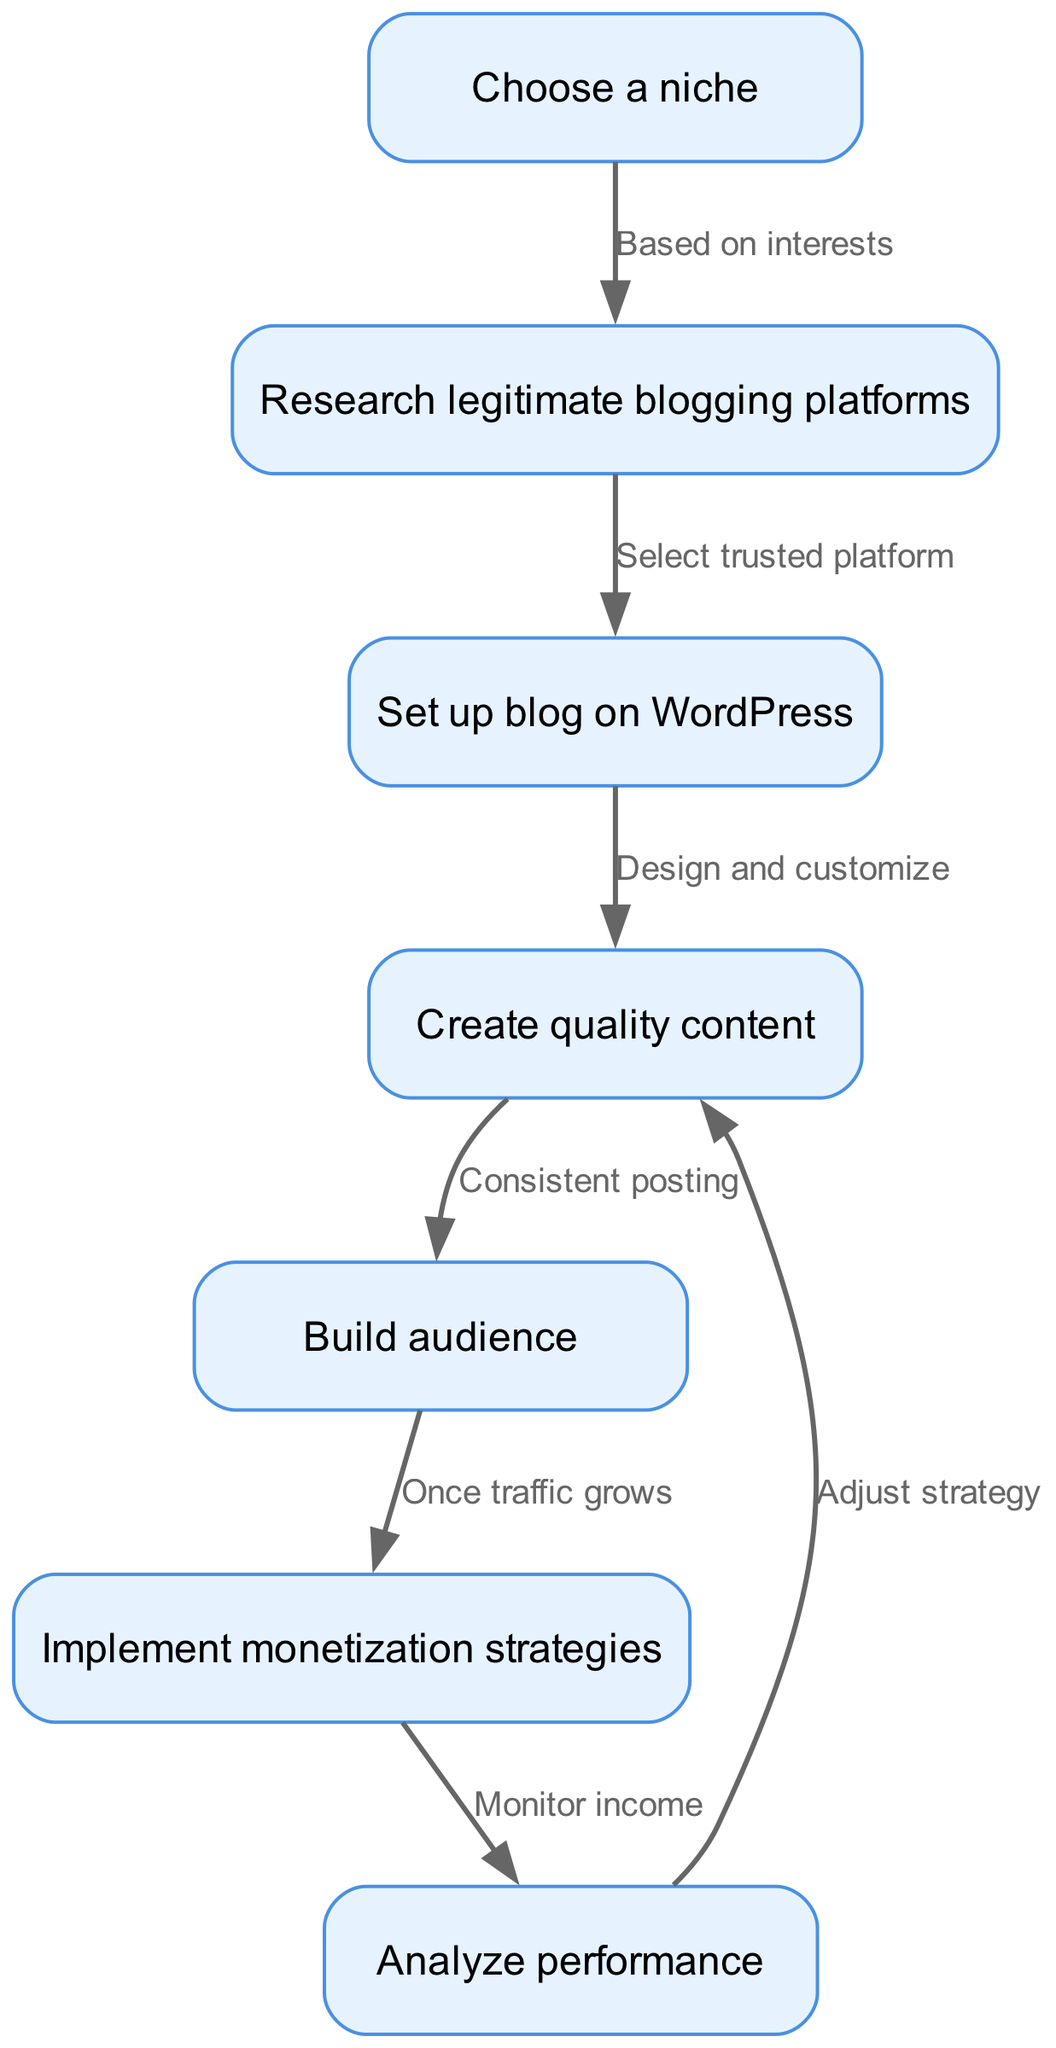What is the first step in creating a blog? The diagram shows the first node as "Choose a niche," indicating that identifying a specific area of interest is the initial step.
Answer: Choose a niche How many nodes are present in the flow chart? The diagram consists of seven nodes, each representing a distinct step in the blogging process.
Answer: 7 What relationship exists between "Build audience" and "Implement monetization strategies"? The flow chart indicates that "Implement monetization strategies" follows from "Build audience" and specifies that it occurs "once traffic grows," highlighting the conditional relationship based on audience growth.
Answer: Once traffic grows What is the last step in the blogging process? According to the flow chart, the final node is "Analyze performance," showing that performance evaluation is the conclusive step after monetization strategies are implemented.
Answer: Analyze performance What does "Create quality content" lead to? The flow chart indicates that "Create quality content" leads to "Build audience," meaning that producing high-quality content is essential for attracting readers.
Answer: Build audience Which node is directly connected to "Set up blog on WordPress"? The diagram shows that "Set up blog on WordPress" is directly followed by "Create quality content," illustrating that once the blog is set up, the next step is to focus on content creation.
Answer: Create quality content What is required to progress from "Choose a niche" to "Research legitimate blogging platforms"? The flow indicates that selecting a niche is based on personal interests, which is the prerequisite to effectively research and find suitable blogging platforms.
Answer: Based on interests What strategy should be monitored after implementing monetization strategies? The flow chart reveals that after monetization strategies are implemented, the next step is to "Analyze performance," indicating that monitoring income is crucial for adjusting strategies.
Answer: Monitor income 